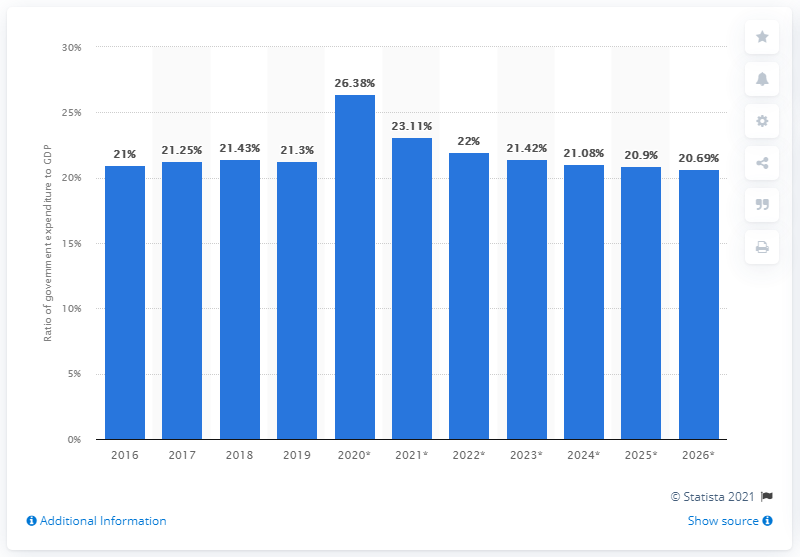Indicate a few pertinent items in this graphic. In 2019, government expenditure in Peru accounted for approximately 21.42% of the country's Gross Domestic Product (GDP). 